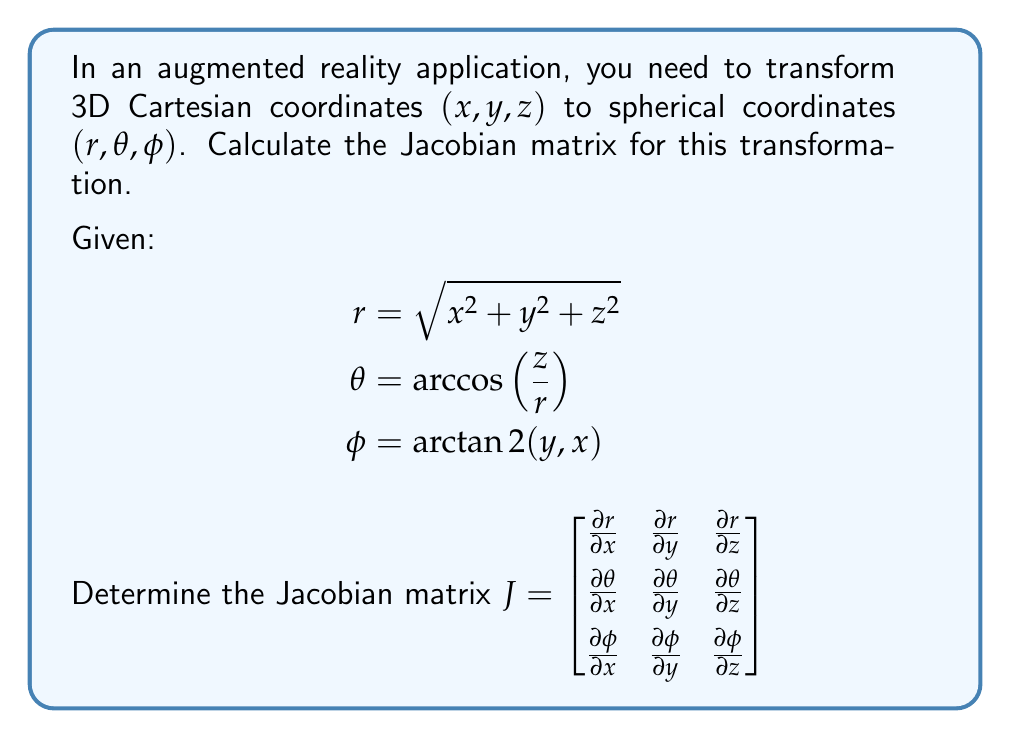Can you solve this math problem? To calculate the Jacobian matrix, we need to find the partial derivatives of each spherical coordinate with respect to each Cartesian coordinate. Let's go through this step-by-step:

1. Calculating $\frac{\partial r}{\partial x}$, $\frac{\partial r}{\partial y}$, and $\frac{\partial r}{\partial z}$:
   $$\frac{\partial r}{\partial x} = \frac{x}{\sqrt{x^2 + y^2 + z^2}} = \frac{x}{r}$$
   $$\frac{\partial r}{\partial y} = \frac{y}{\sqrt{x^2 + y^2 + z^2}} = \frac{y}{r}$$
   $$\frac{\partial r}{\partial z} = \frac{z}{\sqrt{x^2 + y^2 + z^2}} = \frac{z}{r}$$

2. Calculating $\frac{\partial \theta}{\partial x}$, $\frac{\partial \theta}{\partial y}$, and $\frac{\partial \theta}{\partial z}$:
   Using the chain rule and the fact that $\frac{d}{dx}\arccos(x) = -\frac{1}{\sqrt{1-x^2}}$, we get:
   $$\frac{\partial \theta}{\partial x} = -\frac{1}{\sqrt{1-(\frac{z}{r})^2}} \cdot \frac{\partial}{\partial x}\left(\frac{z}{r}\right) = \frac{xz}{r^2\sqrt{x^2+y^2}}$$
   $$\frac{\partial \theta}{\partial y} = -\frac{1}{\sqrt{1-(\frac{z}{r})^2}} \cdot \frac{\partial}{\partial y}\left(\frac{z}{r}\right) = \frac{yz}{r^2\sqrt{x^2+y^2}}$$
   $$\frac{\partial \theta}{\partial z} = -\frac{1}{\sqrt{1-(\frac{z}{r})^2}} \cdot \frac{\partial}{\partial z}\left(\frac{z}{r}\right) = -\frac{\sqrt{x^2+y^2}}{r^2}$$

3. Calculating $\frac{\partial \phi}{\partial x}$, $\frac{\partial \phi}{\partial y}$, and $\frac{\partial \phi}{\partial z}$:
   Using the properties of $\arctan2(y,x)$, we get:
   $$\frac{\partial \phi}{\partial x} = -\frac{y}{x^2+y^2}$$
   $$\frac{\partial \phi}{\partial y} = \frac{x}{x^2+y^2}$$
   $$\frac{\partial \phi}{\partial z} = 0$$

4. Combining all these partial derivatives into the Jacobian matrix:

   $$J = \begin{bmatrix}
   \frac{x}{r} & \frac{y}{r} & \frac{z}{r} \\
   \frac{xz}{r^2\sqrt{x^2+y^2}} & \frac{yz}{r^2\sqrt{x^2+y^2}} & -\frac{\sqrt{x^2+y^2}}{r^2} \\
   -\frac{y}{x^2+y^2} & \frac{x}{x^2+y^2} & 0
   \end{bmatrix}$$

This Jacobian matrix represents the linear approximation of the transformation from Cartesian to spherical coordinates at any given point $(x, y, z)$.
Answer: $$J = \begin{bmatrix}
\frac{x}{r} & \frac{y}{r} & \frac{z}{r} \\
\frac{xz}{r^2\sqrt{x^2+y^2}} & \frac{yz}{r^2\sqrt{x^2+y^2}} & -\frac{\sqrt{x^2+y^2}}{r^2} \\
-\frac{y}{x^2+y^2} & \frac{x}{x^2+y^2} & 0
\end{bmatrix}$$ 